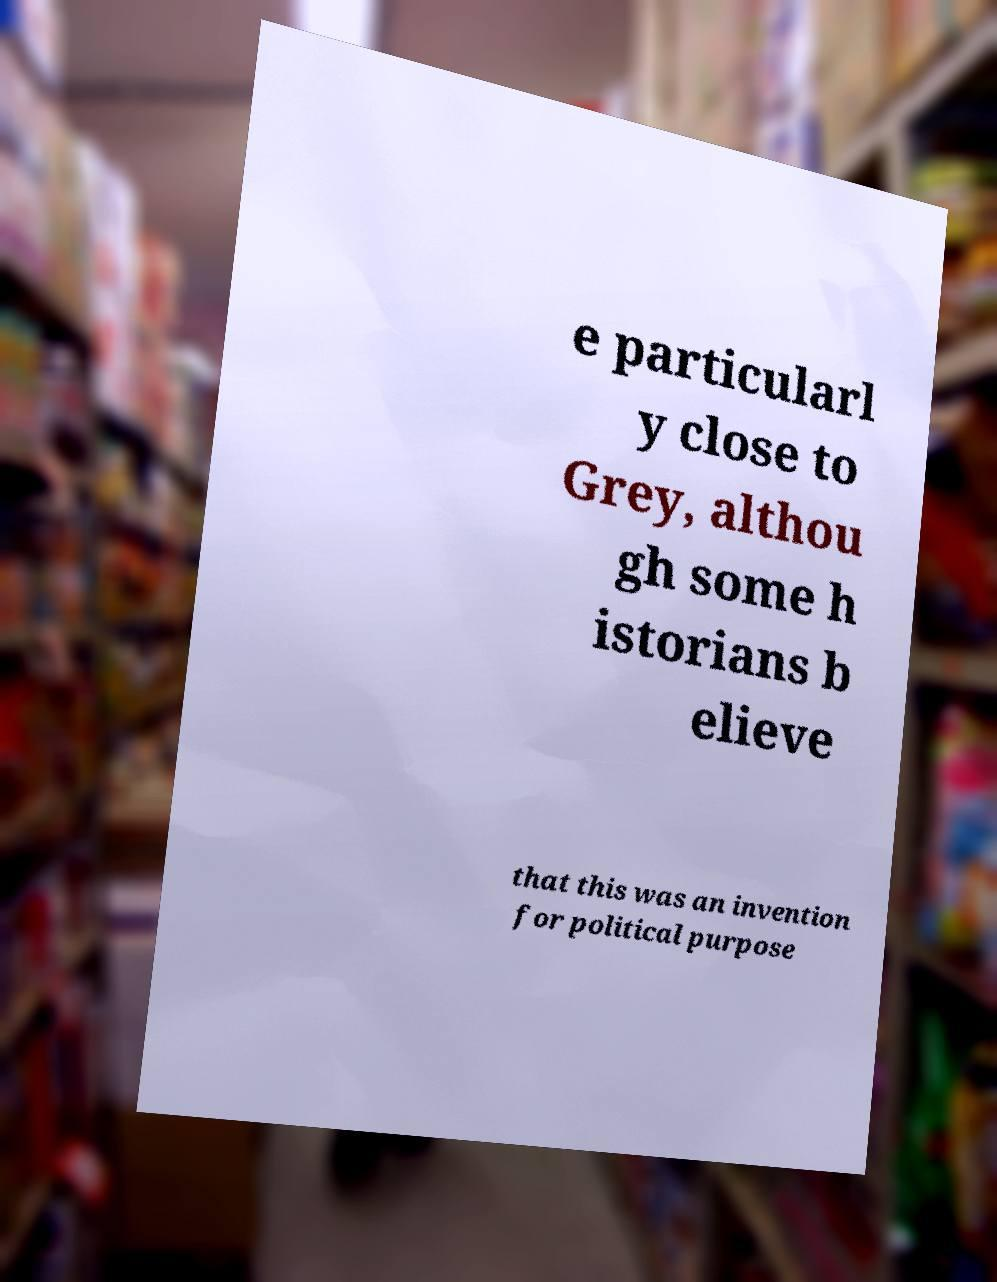Could you extract and type out the text from this image? e particularl y close to Grey, althou gh some h istorians b elieve that this was an invention for political purpose 